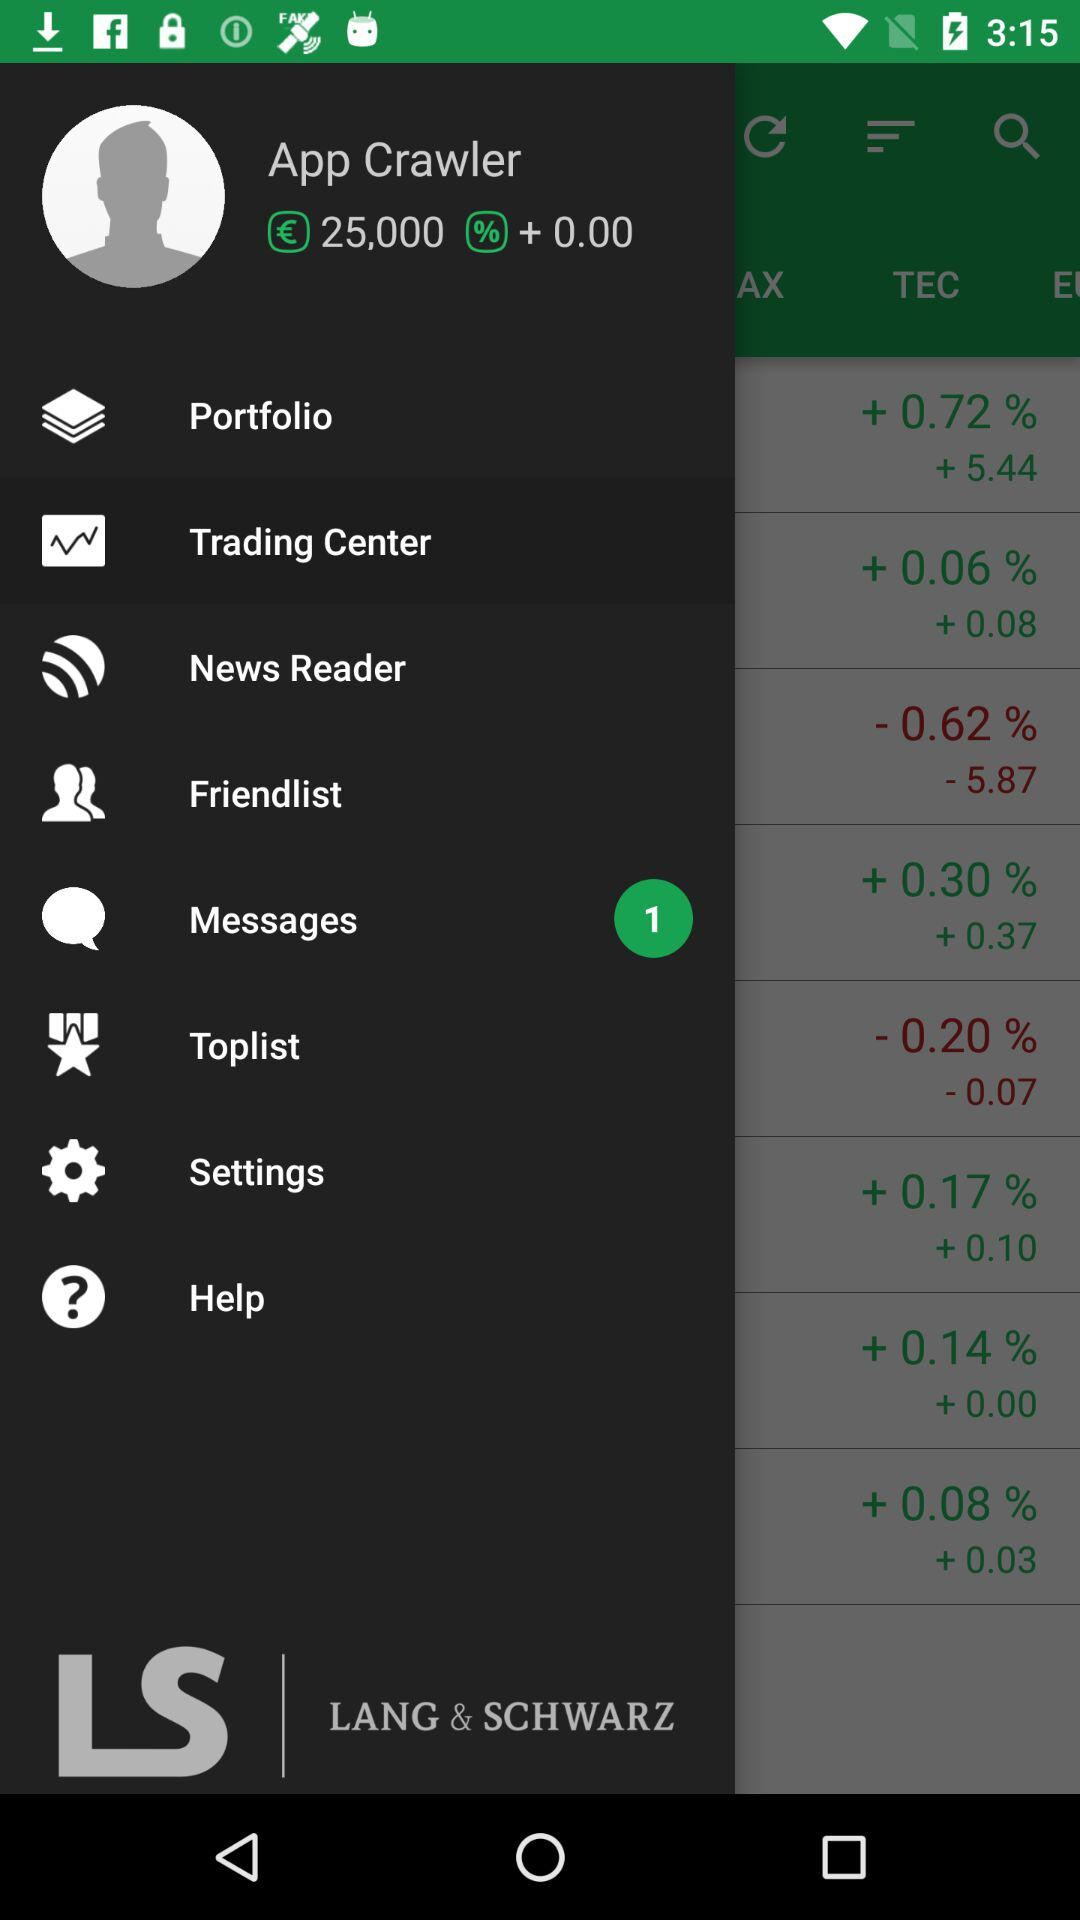How many unread messages are there? There is 1 unread message. 